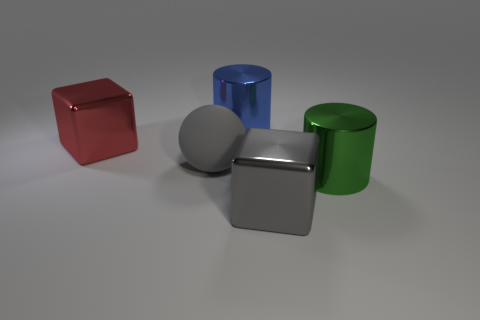How many matte objects are blocks or large blue cylinders?
Your answer should be very brief. 0. Is there a big blue metallic thing?
Provide a short and direct response. Yes. What is the color of the rubber thing in front of the metallic cylinder that is left of the large gray metallic thing?
Your response must be concise. Gray. What number of other objects are the same color as the big matte object?
Your answer should be very brief. 1. What number of things are small red things or metal blocks that are on the right side of the big red metal cube?
Provide a short and direct response. 1. There is a large block on the left side of the rubber thing; what color is it?
Keep it short and to the point. Red. What is the shape of the large red metallic thing?
Give a very brief answer. Cube. The big cube behind the big metal cube to the right of the red metallic block is made of what material?
Offer a very short reply. Metal. How many other things are there of the same material as the red cube?
Your answer should be compact. 3. There is a gray ball that is the same size as the red shiny object; what material is it?
Your response must be concise. Rubber. 